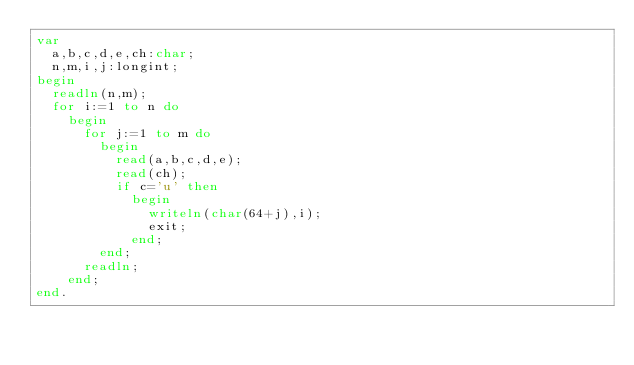Convert code to text. <code><loc_0><loc_0><loc_500><loc_500><_Pascal_>var
  a,b,c,d,e,ch:char;
  n,m,i,j:longint;
begin
  readln(n,m);
  for i:=1 to n do
    begin
      for j:=1 to m do
        begin
          read(a,b,c,d,e);
          read(ch);
          if c='u' then
            begin
              writeln(char(64+j),i);
              exit;
            end;
        end;
      readln;
    end;
end.</code> 